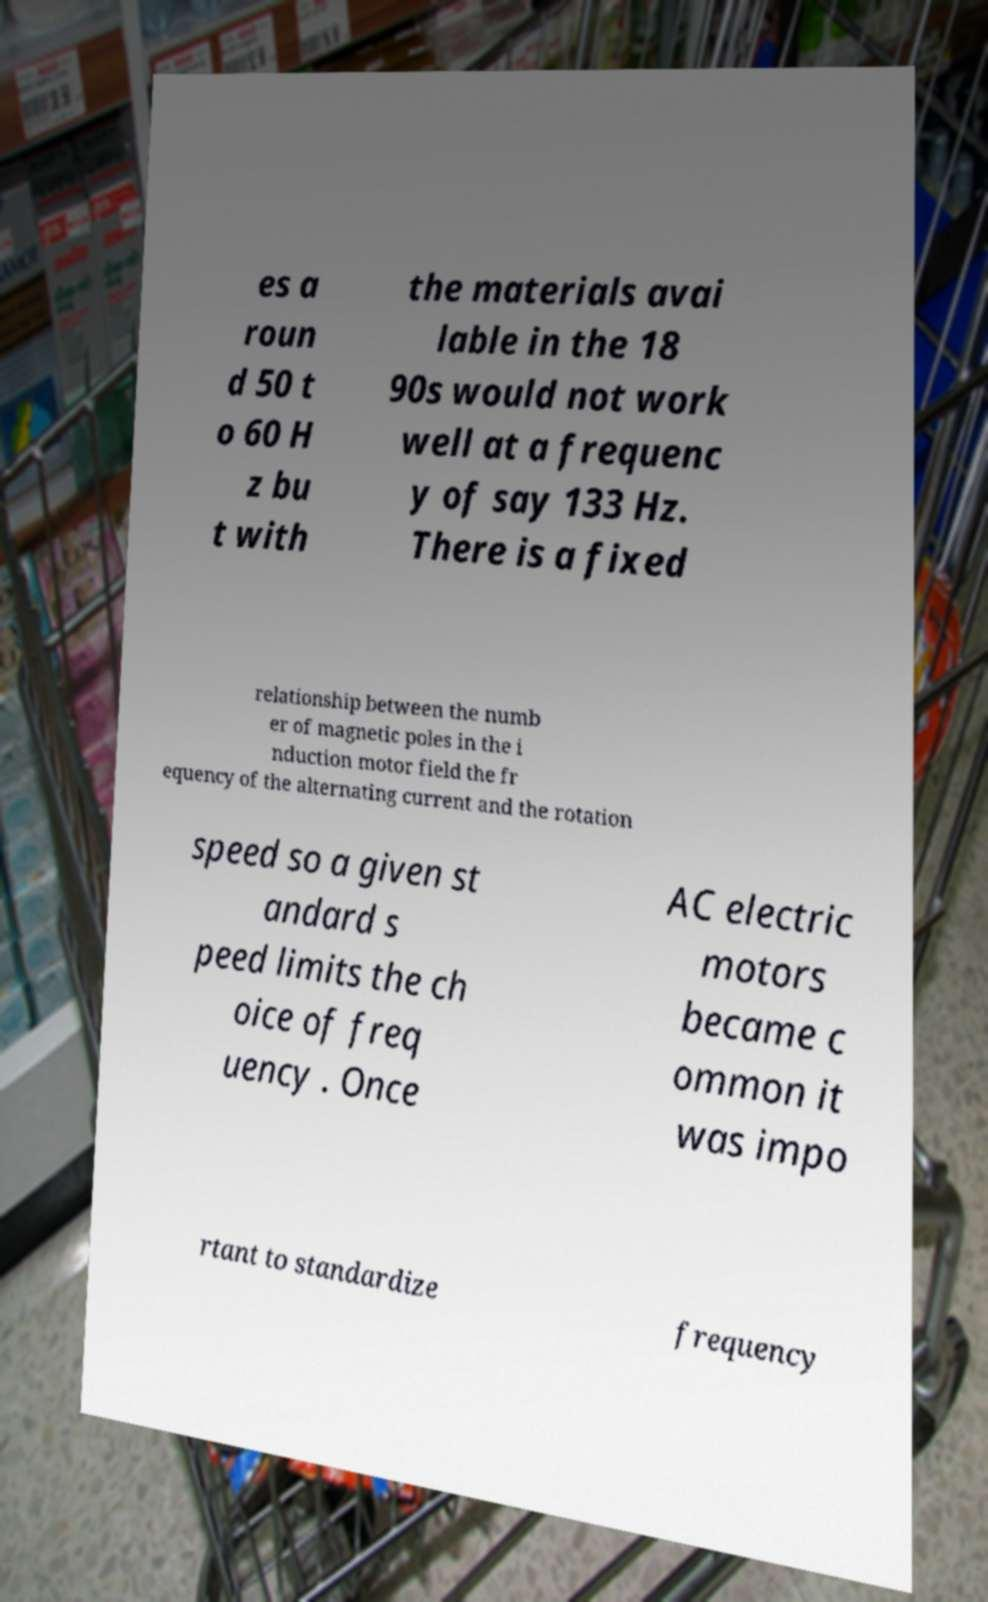Please read and relay the text visible in this image. What does it say? es a roun d 50 t o 60 H z bu t with the materials avai lable in the 18 90s would not work well at a frequenc y of say 133 Hz. There is a fixed relationship between the numb er of magnetic poles in the i nduction motor field the fr equency of the alternating current and the rotation speed so a given st andard s peed limits the ch oice of freq uency . Once AC electric motors became c ommon it was impo rtant to standardize frequency 